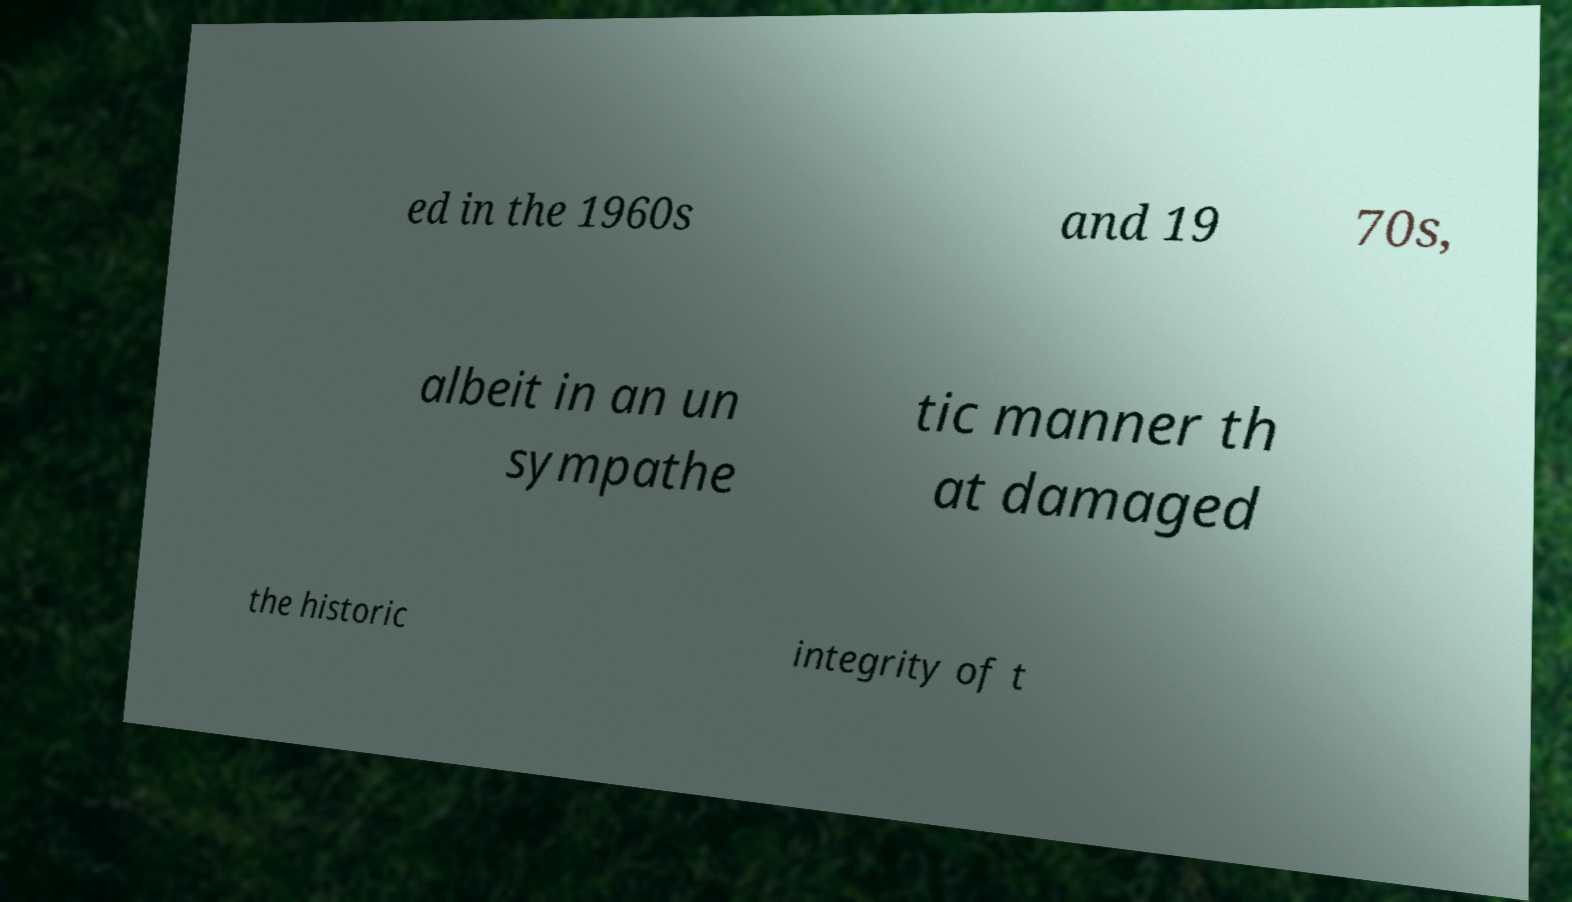Please read and relay the text visible in this image. What does it say? ed in the 1960s and 19 70s, albeit in an un sympathe tic manner th at damaged the historic integrity of t 